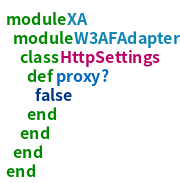Convert code to text. <code><loc_0><loc_0><loc_500><loc_500><_Ruby_>module XA
  module W3AFAdapter
    class HttpSettings
      def proxy?
        false
      end
    end
  end
end
</code> 